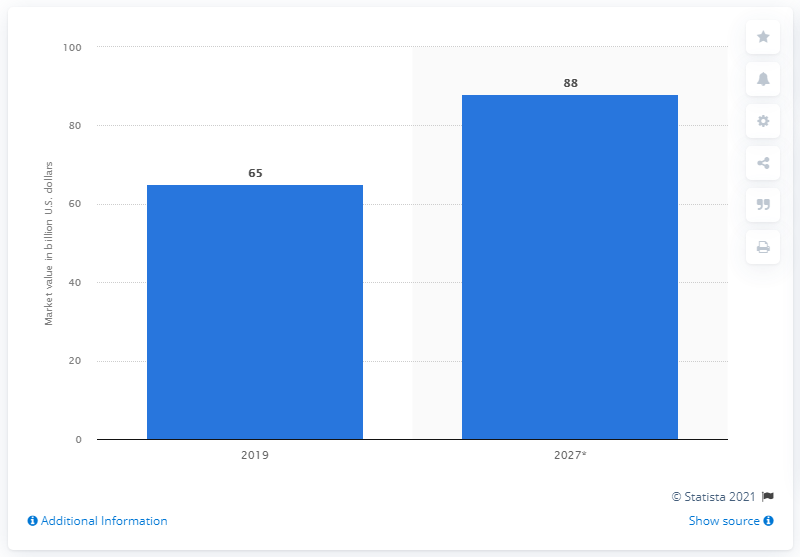Outline some significant characteristics in this image. The estimated global market value of PVC in 2027 is projected to be approximately $88 billion. 